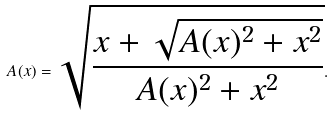<formula> <loc_0><loc_0><loc_500><loc_500>A ( x ) = \sqrt { \frac { x + \sqrt { A ( x ) ^ { 2 } + x ^ { 2 } } } { A ( x ) ^ { 2 } + x ^ { 2 } } } .</formula> 